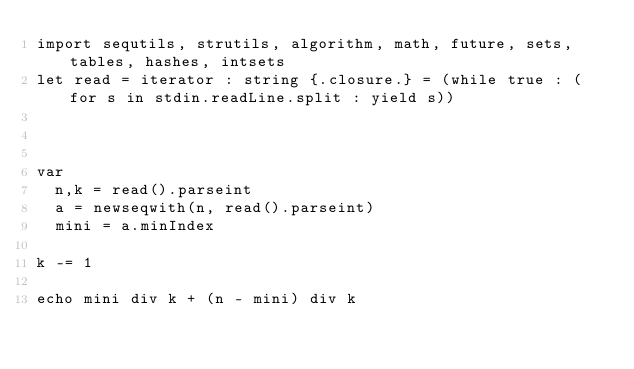<code> <loc_0><loc_0><loc_500><loc_500><_Nim_>import sequtils, strutils, algorithm, math, future, sets, tables, hashes, intsets
let read = iterator : string {.closure.} = (while true : (for s in stdin.readLine.split : yield s))



var
  n,k = read().parseint
  a = newseqwith(n, read().parseint)
  mini = a.minIndex

k -= 1

echo mini div k + (n - mini) div k</code> 